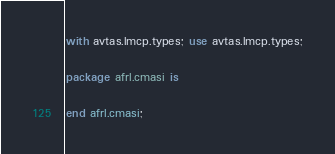Convert code to text. <code><loc_0><loc_0><loc_500><loc_500><_Ada_>with avtas.lmcp.types; use avtas.lmcp.types;

package afrl.cmasi is

end afrl.cmasi;
</code> 